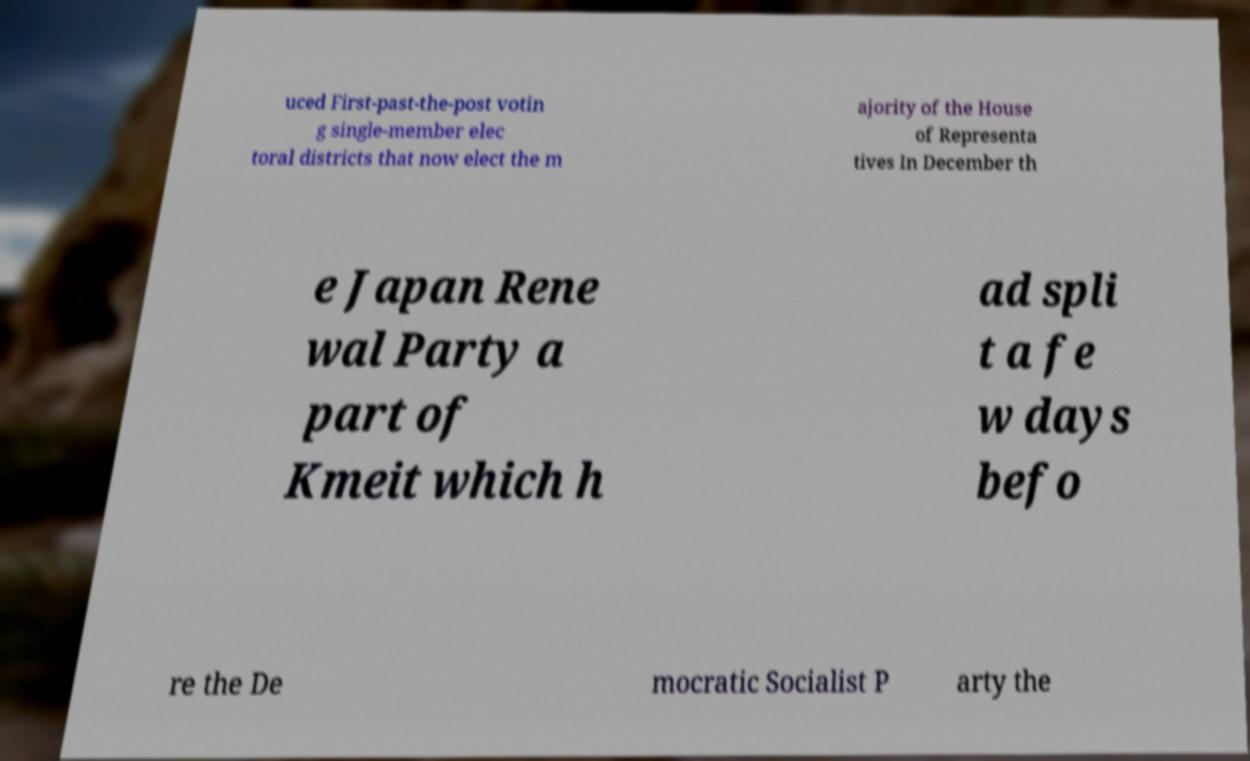Can you read and provide the text displayed in the image?This photo seems to have some interesting text. Can you extract and type it out for me? uced First-past-the-post votin g single-member elec toral districts that now elect the m ajority of the House of Representa tives In December th e Japan Rene wal Party a part of Kmeit which h ad spli t a fe w days befo re the De mocratic Socialist P arty the 